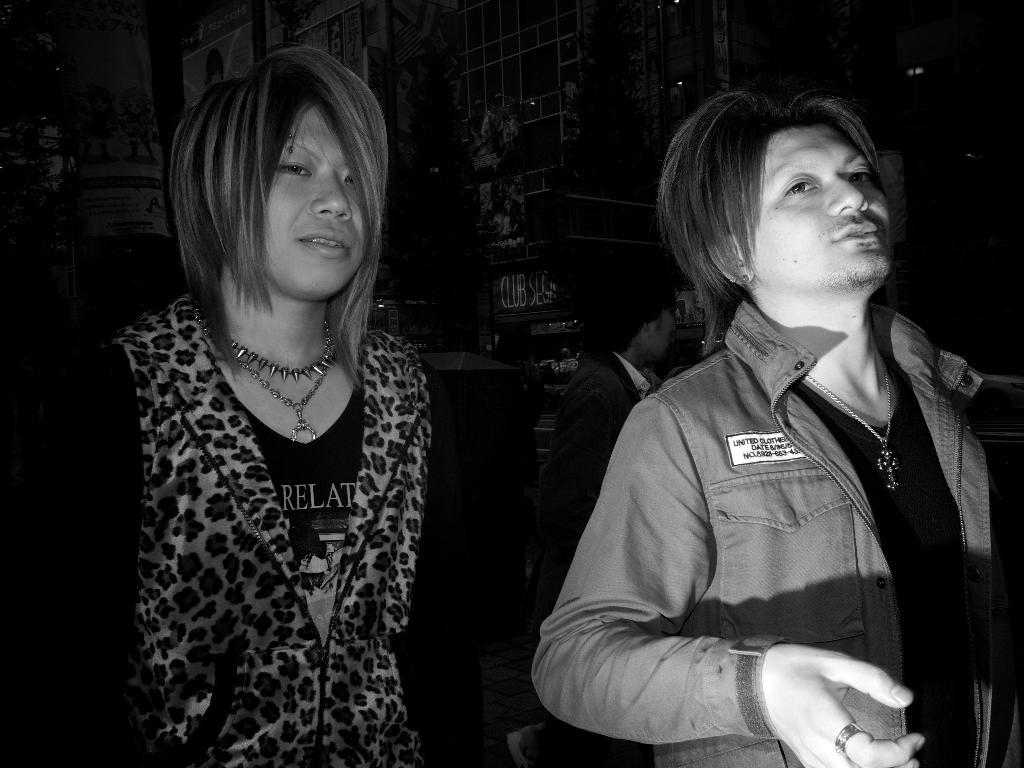How many people are present in the image? There are two persons in the image. What can be observed about the background of the image? The background of the image is dark. Can you describe the presence of any additional people in the image? There is another person visible at the backside of the two persons. What type of authority figure can be seen holding sticks in the image? There is no authority figure or sticks present in the image. 